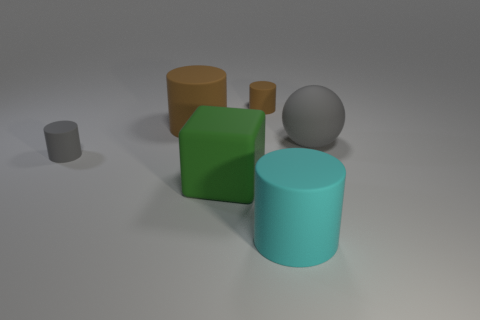Is the tiny cylinder that is behind the gray rubber cylinder made of the same material as the big ball?
Make the answer very short. Yes. What is the material of the small object behind the gray rubber object in front of the sphere?
Your response must be concise. Rubber. How many other large matte objects are the same shape as the big brown rubber thing?
Your answer should be compact. 1. What is the size of the gray matte object left of the gray object that is behind the small rubber cylinder to the left of the big green object?
Your answer should be compact. Small. What number of red objects are either cylinders or big matte cubes?
Give a very brief answer. 0. Is the shape of the tiny object that is on the right side of the large brown rubber object the same as  the big brown rubber object?
Your response must be concise. Yes. Are there more rubber things on the left side of the big green object than yellow matte blocks?
Offer a very short reply. Yes. What number of matte things have the same size as the cyan matte cylinder?
Provide a succinct answer. 3. There is a matte cylinder that is the same color as the matte sphere; what size is it?
Ensure brevity in your answer.  Small. What number of things are either cyan things or gray rubber cylinders that are left of the big matte sphere?
Your response must be concise. 2. 